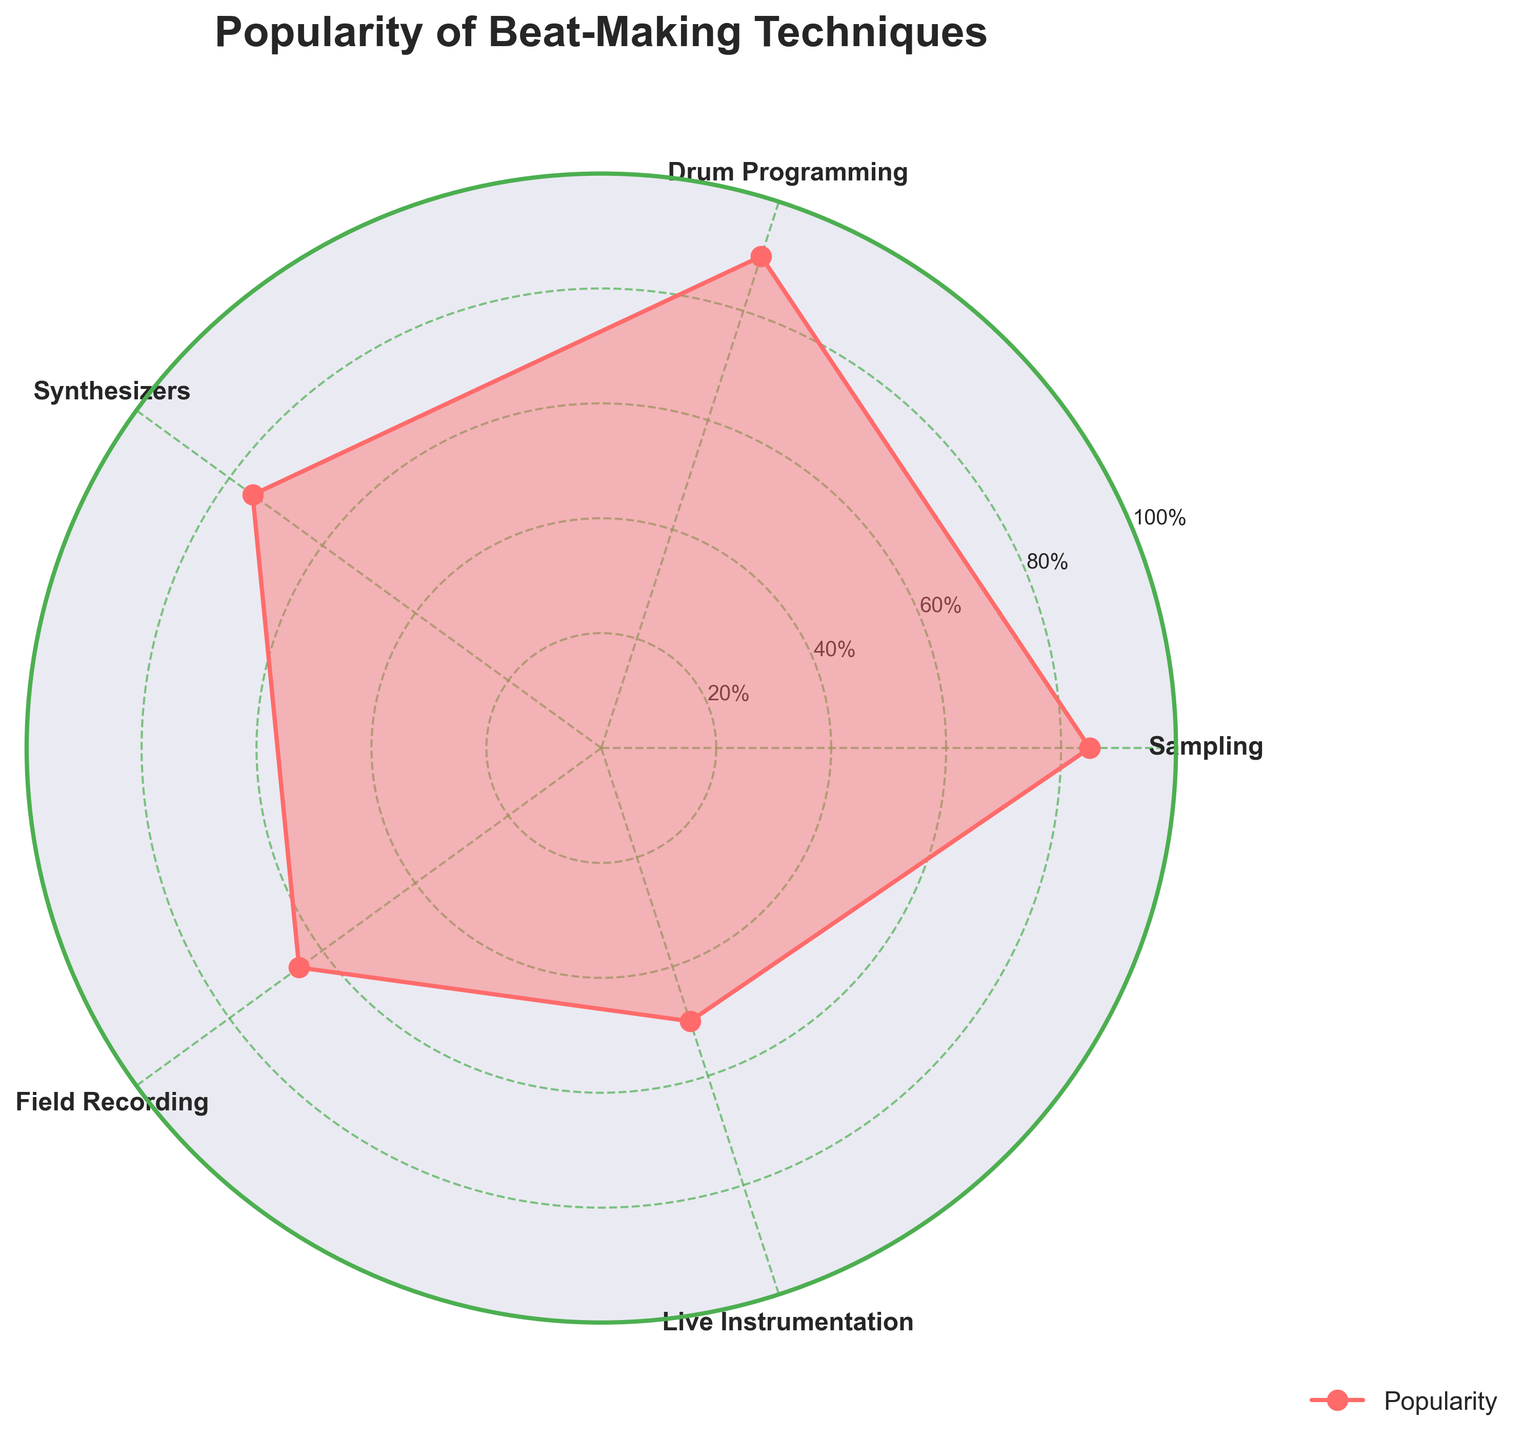What's the title of the radar chart? The title of the chart is shown at the top and it tells us what the chart is about. The title reads "Popularity of Beat-Making Techniques."
Answer: Popularity of Beat-Making Techniques Which technique has the highest popularity percentage? To determine the technique with the highest popularity, we look for the one that reaches the farthest on the chart. Drum Programming has the highest value at 90%.
Answer: Drum Programming What is the difference in popularity percentage between Sampling and Live Instrumentation? The popularity of Sampling is 85% and Live Instrumentation is 50%. To find the difference, subtract 50% from 85%, which is 35%.
Answer: 35% Which technique is least popular, and what is its popularity percentage? The least popular technique is the one closest to the center of the radar chart. Live Instrumentation is the least popular with a percentage of 50%.
Answer: Live Instrumentation, 50% What are the visual features that indicate the popularity percentages? The visual features include the distance from the center to each technique on the chart, the filled area, and the labels at each axis. Higher percentages reach farther from the center, making them easier to compare.
Answer: Distance from center, filled area, and axis labels Rank all the techniques from most to least popular. To rank the techniques, list them based on their percentages from highest to lowest. Drum Programming is first (90%), followed by Sampling (85%), Synthesizers (75%), Field Recording (65%), and Live Instrumentation (50%).
Answer: Drum Programming, Sampling, Synthesizers, Field Recording, Live Instrumentation What is the average popularity percentage of all techniques? To find the average, sum all the popularity percentages and divide by the number of techniques: (85% + 90% + 75% + 65% + 50%) / 5 = 73%.
Answer: 73% By how much does Field Recording's popularity fall short compared to Drum Programming? Field Recording has a popularity of 65%, and Drum Programming has 90%. Subtract 65% from 90% to find the shortfall, which is 25%.
Answer: 25% Which technique shows the median popularity, and what is its percentage? To find the median, the techniques need to be ordered by popularity percentages: Live Instrumentation (50%), Field Recording (65%), Synthesizers (75%), Sampling (85%), Drum Programming (90%). The median is the middle value, which is Synthesizers at 75%.
Answer: Synthesizers, 75% 